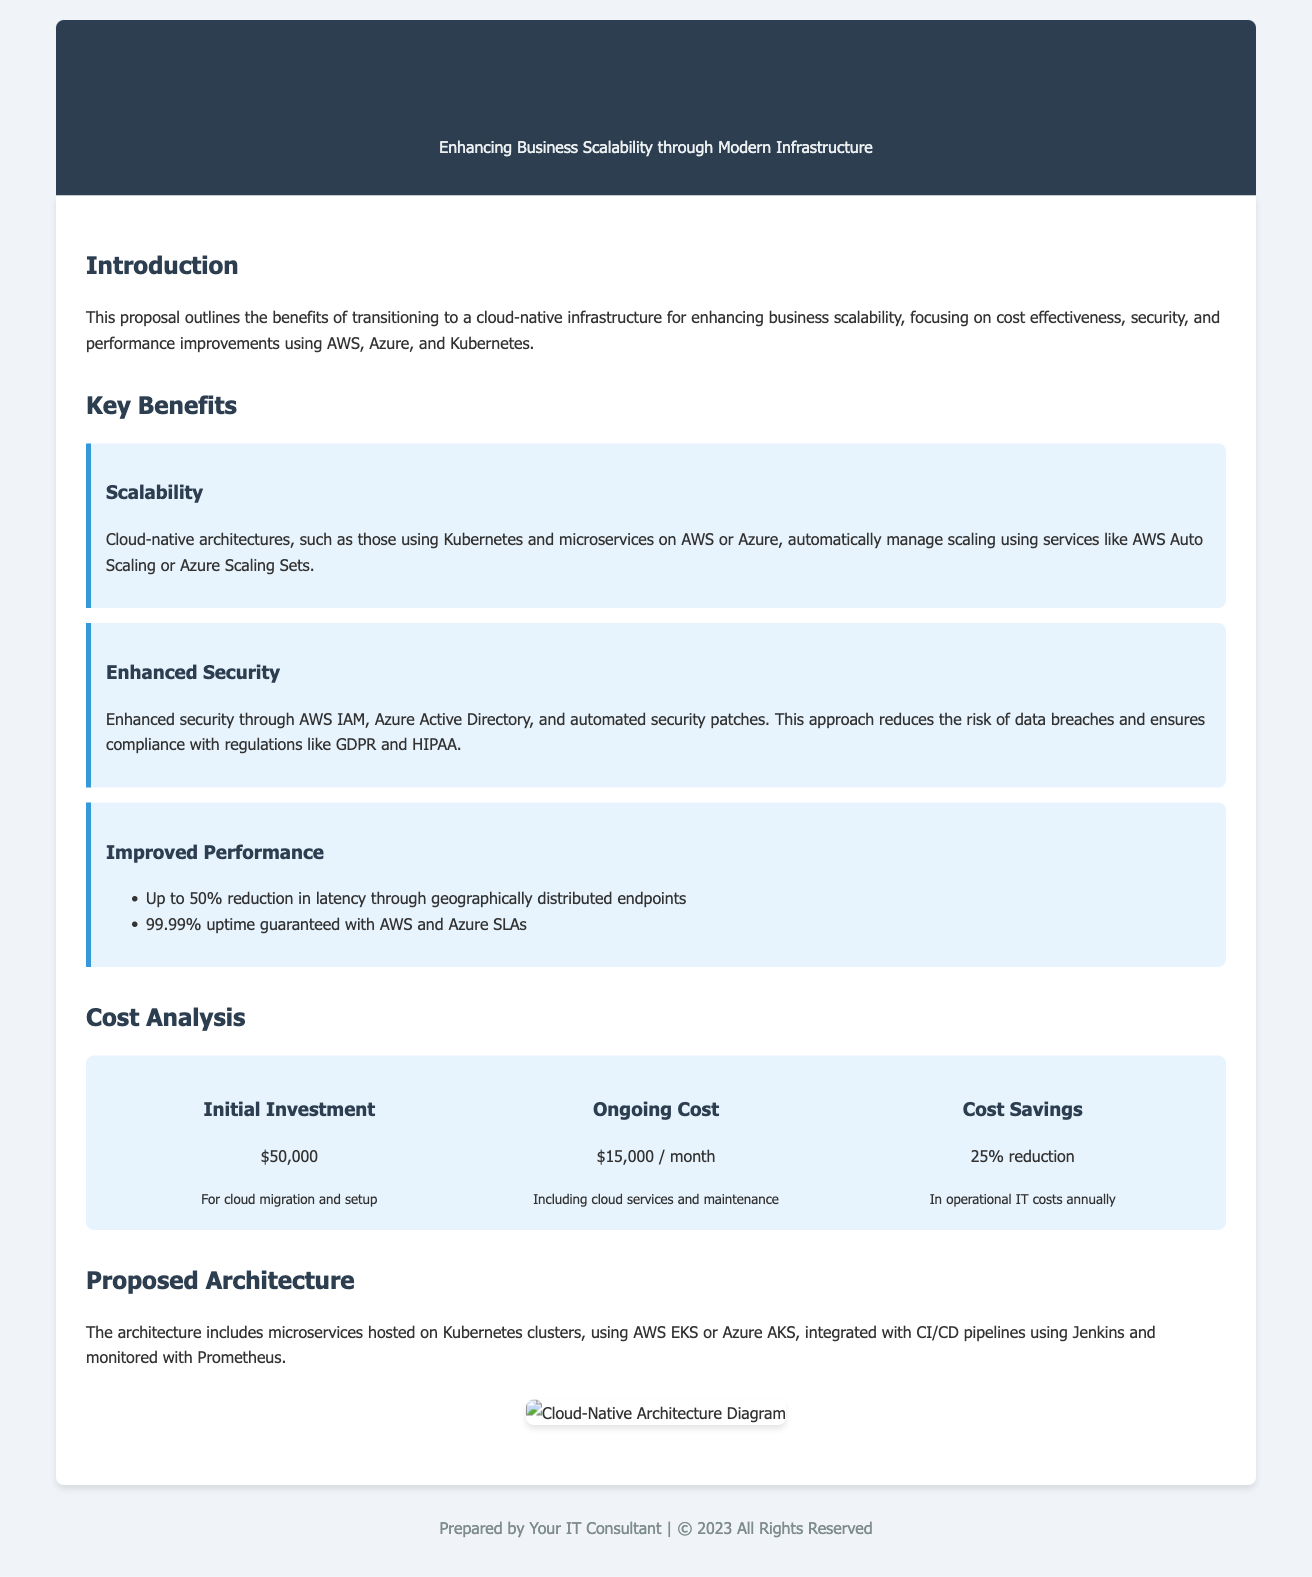What is the proposal about? The proposal outlines the benefits of transitioning to a cloud-native infrastructure for enhancing business scalability.
Answer: Cloud-Native Architecture What technologies are mentioned for implementing the architecture? The document lists AWS, Azure, and Kubernetes as technologies for the cloud-native architecture.
Answer: AWS, Azure, Kubernetes What is the initial investment cost? The initial investment cost for cloud migration and setup is specified in the cost analysis section of the document.
Answer: $50,000 What percentage reduction in operational IT costs is projected? The document states a forecasted decrease in operational IT costs after implementing the proposal.
Answer: 25% What is one of the performance improvements mentioned? The proposal mentions a specific percentage reduction in latency as a key performance improvement.
Answer: Up to 50% Which CI/CD tool is referenced in the proposed architecture? The document identifies a specific CI/CD tool that will be used in the cloud-native architecture.
Answer: Jenkins What is the ongoing monthly cost for the cloud services? The ongoing cost section of the document provides the monthly expense for cloud services and maintenance.
Answer: $15,000 What is one of the benefits of cloud-native architecture? The document highlights a key benefit of adopting a cloud-native architecture in relation to scalability.
Answer: Scalability 